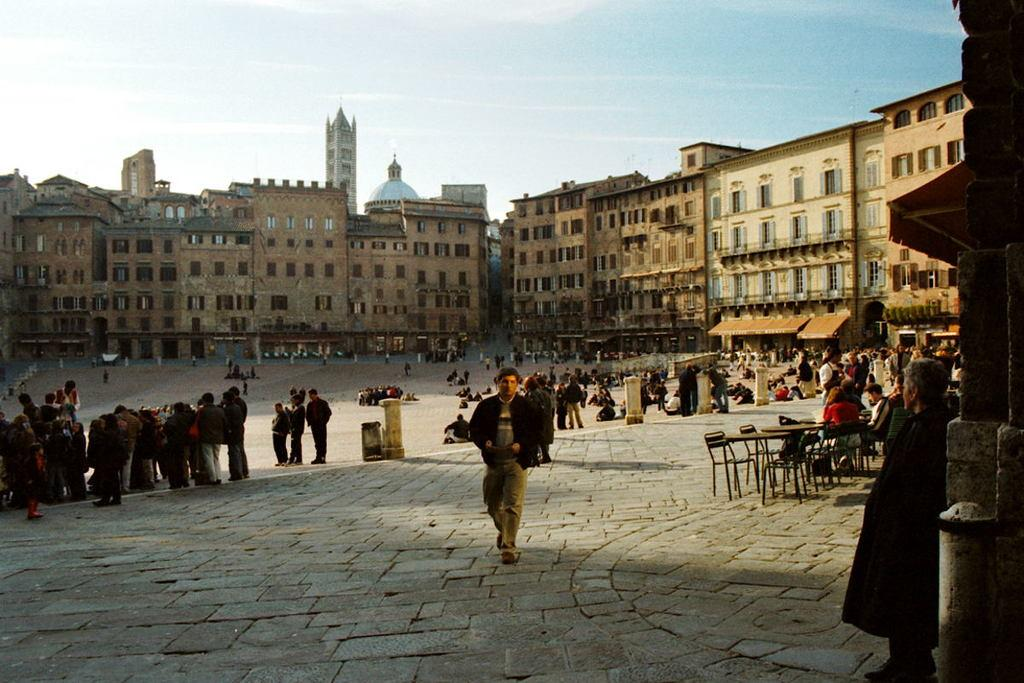What is happening in the image? There is a group of people standing in the image. What type of furniture is present in the image? There are chairs and tables in the image. What can be seen in the background of the image? There are buildings and the sky visible in the background of the image. Where is the mother sitting with her ant in the lunchroom in the image? There is no mother, ant, or lunchroom present in the image. 